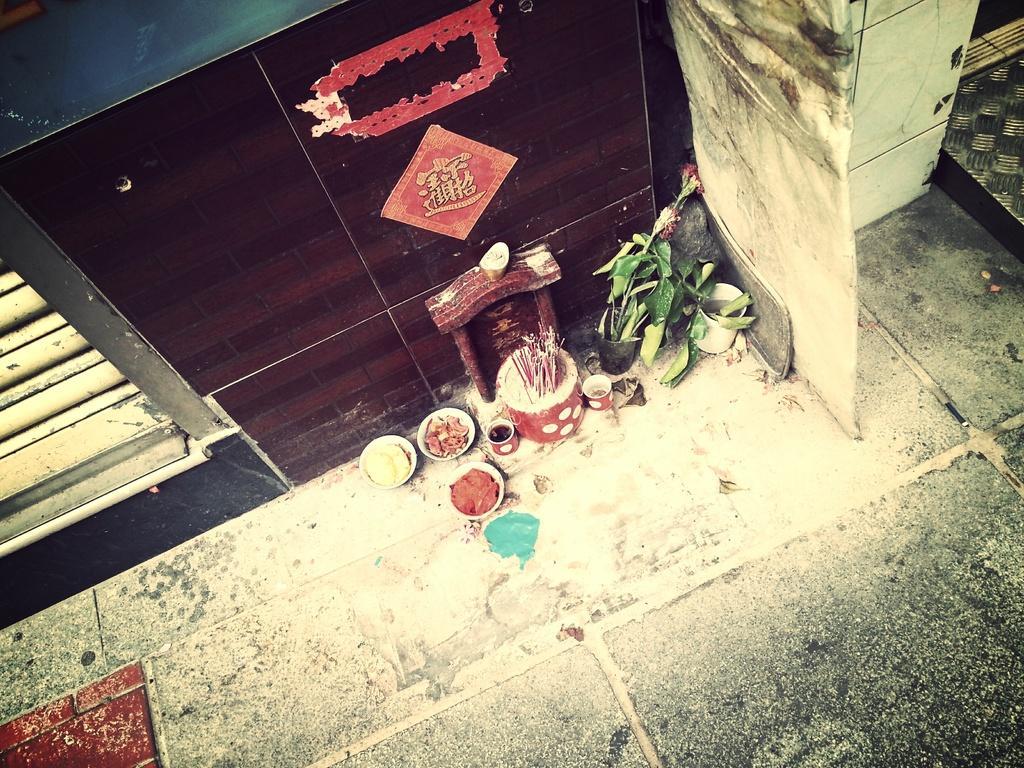How would you summarize this image in a sentence or two? In the middle of the picture, we see flower pots, red color object which looks like a box, bowls and cups. Beside that, we see a wooden stool. Beside that, we see a wall in brown color. On the left side, we see the window. In the right top, we see the white pillar. 